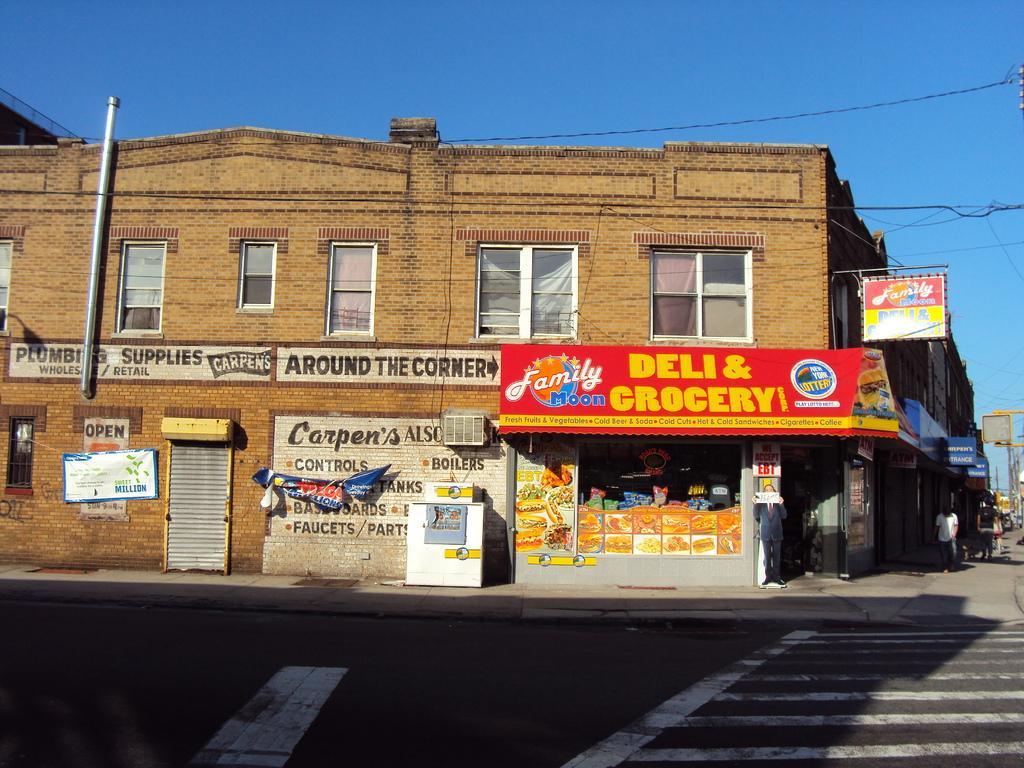In one or two sentences, can you explain what this image depicts? In this picture I can see a building, there are boards, banners, cables, there are group of people, there is an air conditioner, there is road, and in the background there is sky. 